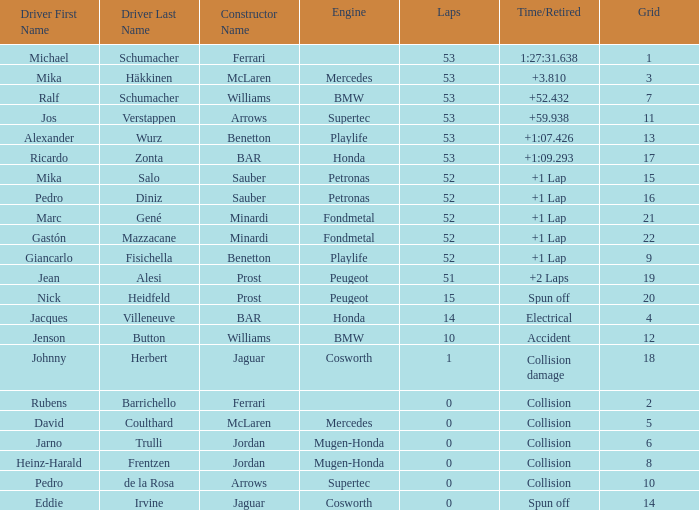What is the identity of the ferrari driver with a grid position below 14, less than 53 laps completed, and a time/retired status indicating a collision? Rubens Barrichello. 